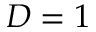<formula> <loc_0><loc_0><loc_500><loc_500>D = 1</formula> 